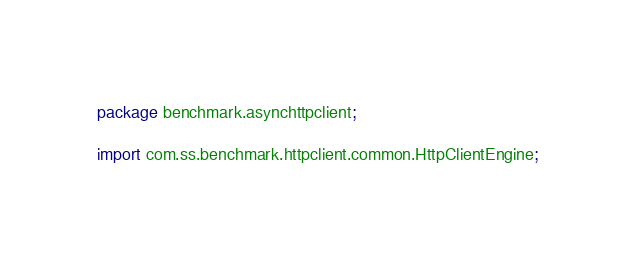Convert code to text. <code><loc_0><loc_0><loc_500><loc_500><_Java_>package benchmark.asynchttpclient;

import com.ss.benchmark.httpclient.common.HttpClientEngine;</code> 